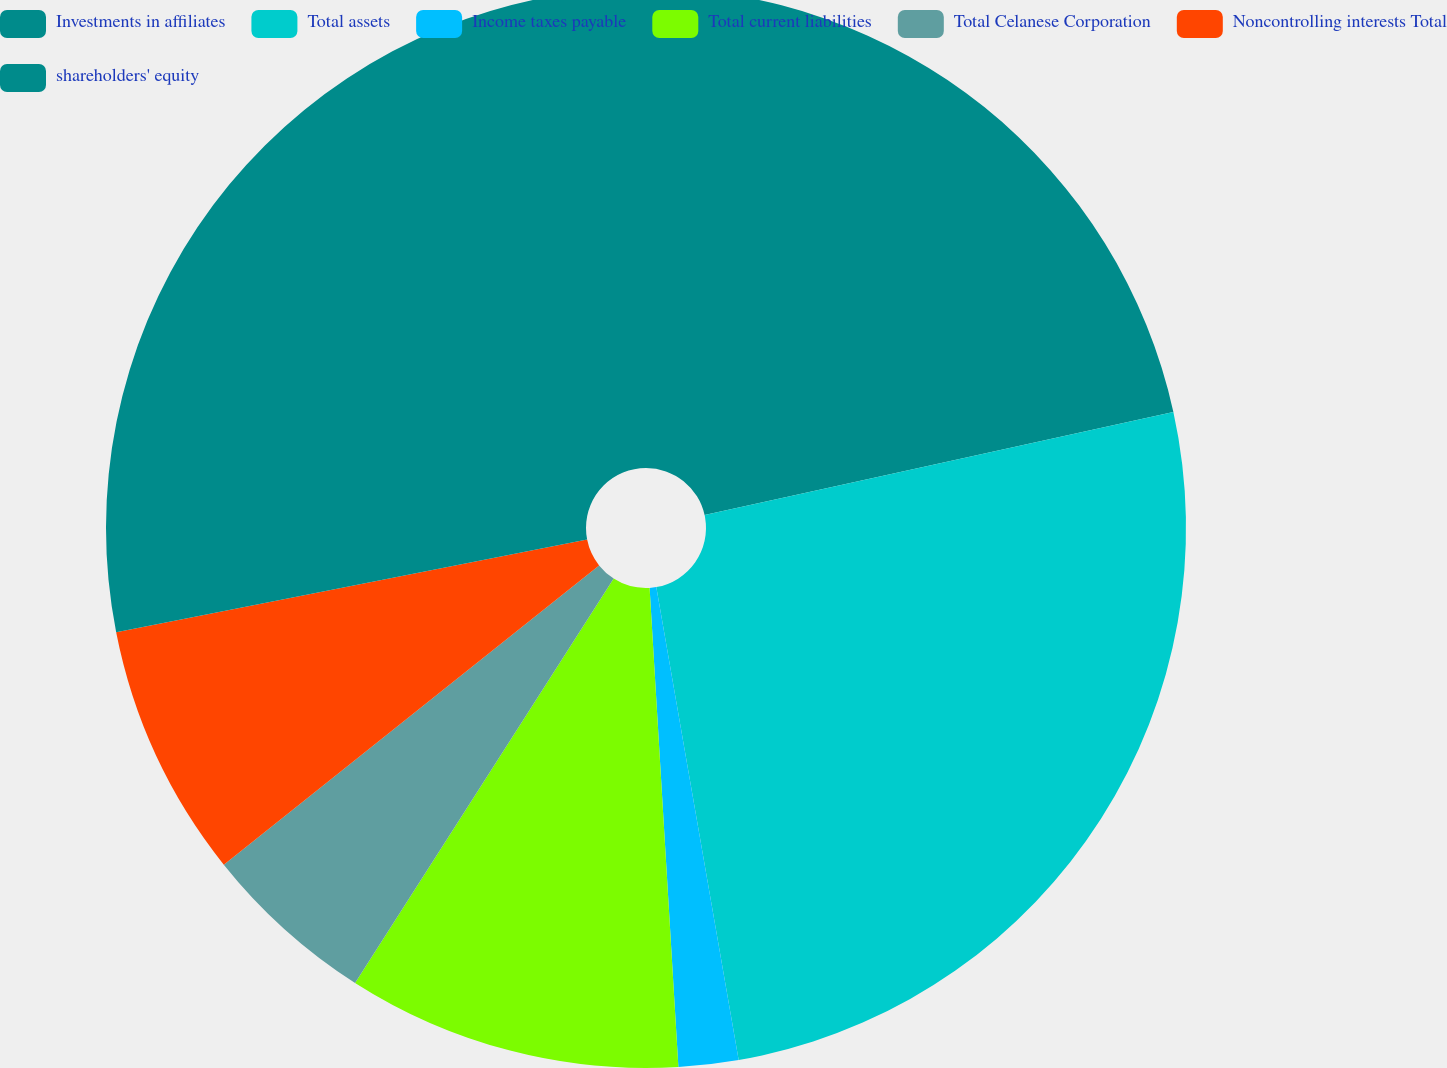Convert chart. <chart><loc_0><loc_0><loc_500><loc_500><pie_chart><fcel>Investments in affiliates<fcel>Total assets<fcel>Income taxes payable<fcel>Total current liabilities<fcel>Total Celanese Corporation<fcel>Noncontrolling interests Total<fcel>shareholders' equity<nl><fcel>21.55%<fcel>25.7%<fcel>1.79%<fcel>10.01%<fcel>5.23%<fcel>7.62%<fcel>28.09%<nl></chart> 